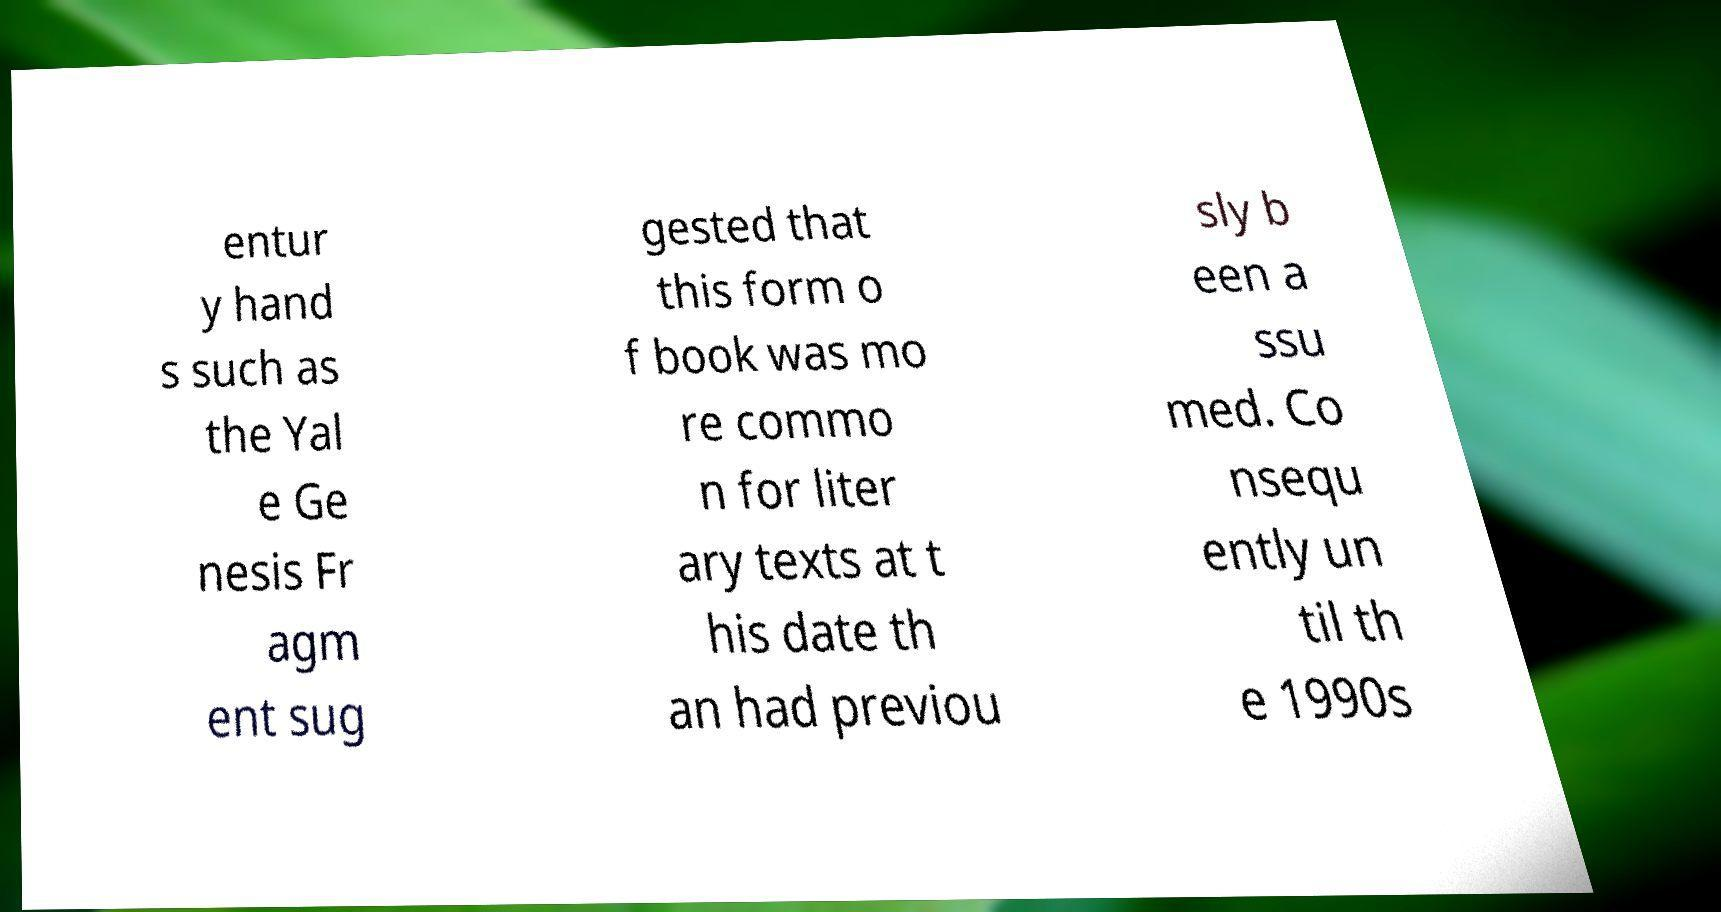Could you extract and type out the text from this image? entur y hand s such as the Yal e Ge nesis Fr agm ent sug gested that this form o f book was mo re commo n for liter ary texts at t his date th an had previou sly b een a ssu med. Co nsequ ently un til th e 1990s 